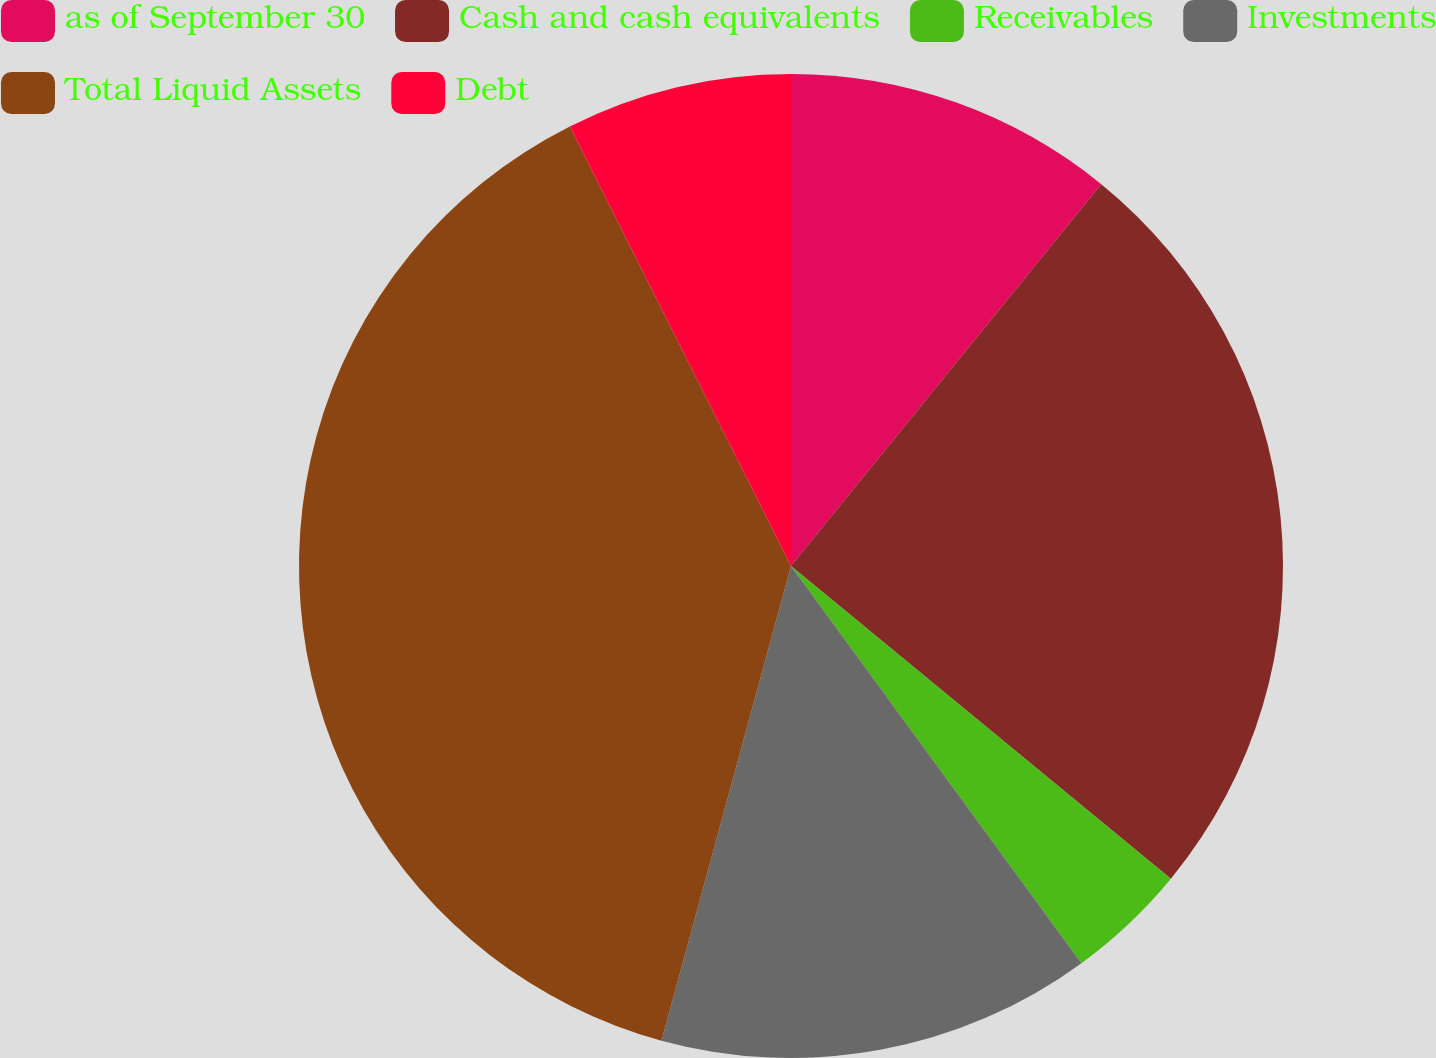Convert chart. <chart><loc_0><loc_0><loc_500><loc_500><pie_chart><fcel>as of September 30<fcel>Cash and cash equivalents<fcel>Receivables<fcel>Investments<fcel>Total Liquid Assets<fcel>Debt<nl><fcel>10.86%<fcel>25.1%<fcel>3.99%<fcel>14.29%<fcel>38.34%<fcel>7.42%<nl></chart> 